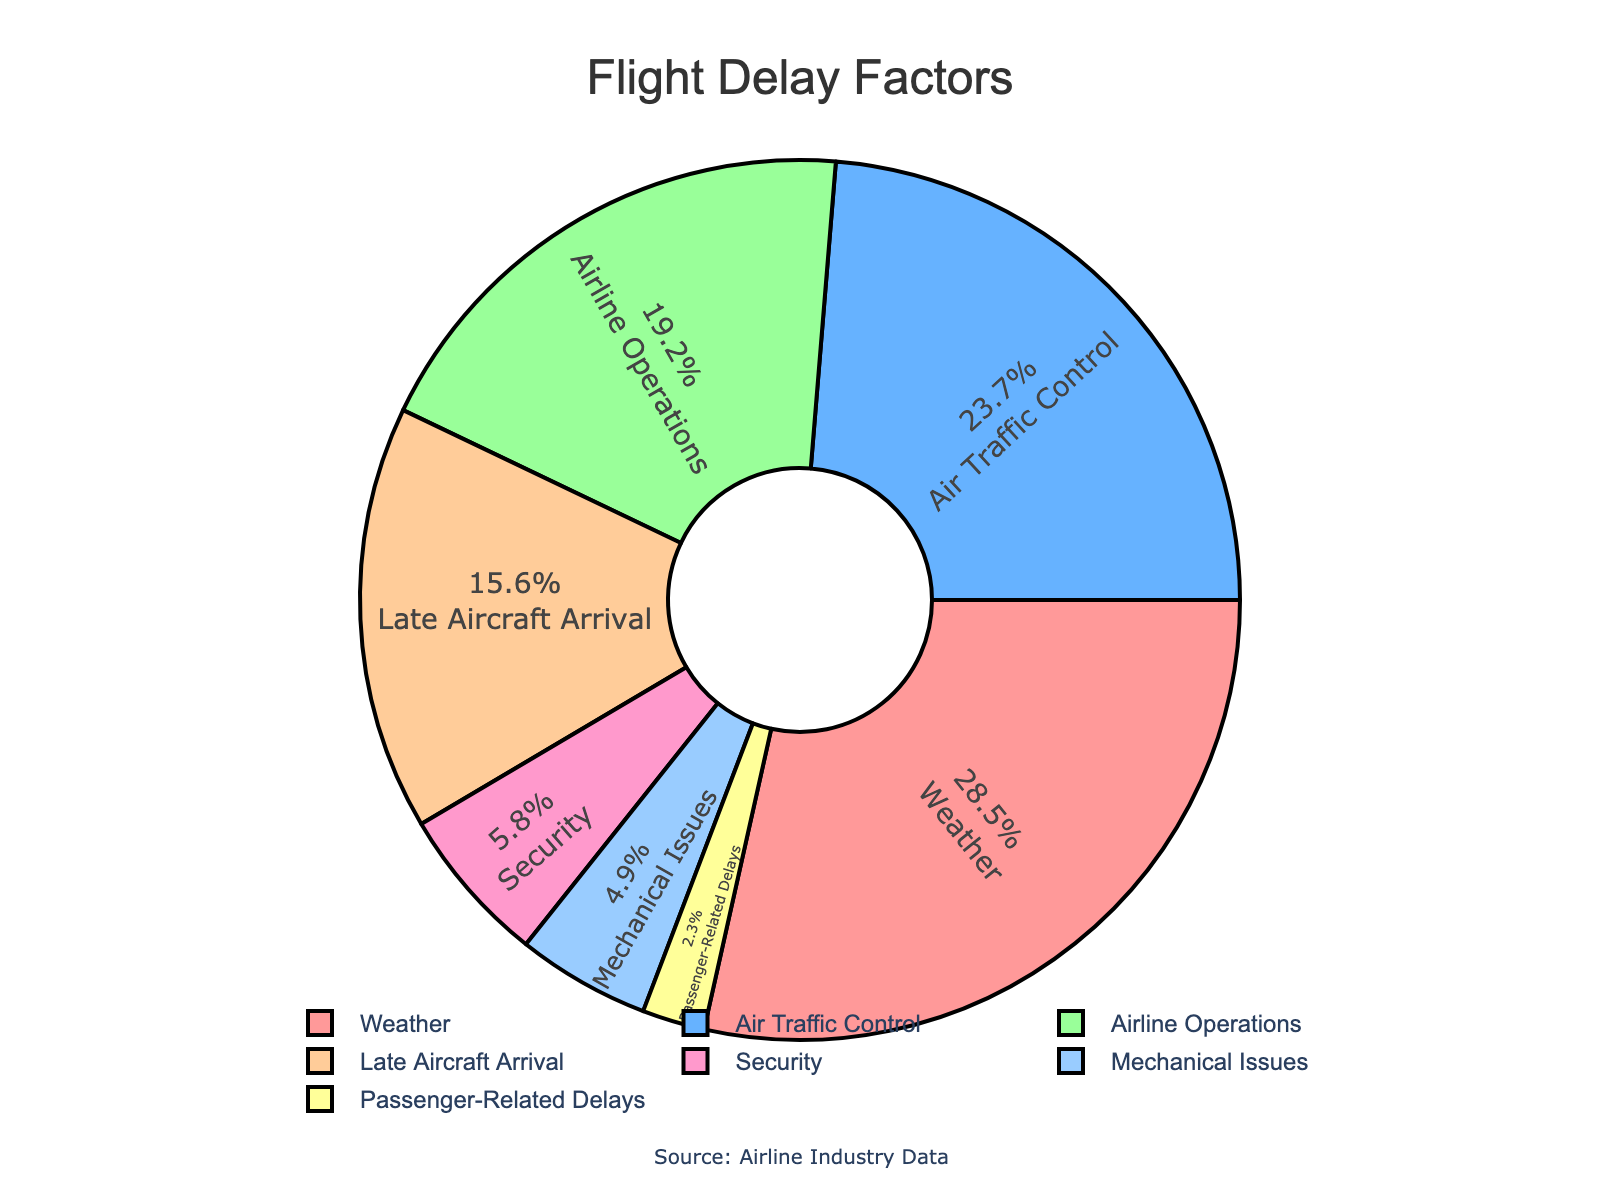What are the top three factors contributing to flight delays? Refer to the pie chart and identify the three largest sections by percentage. The top three factors are Weather (28.5%), Air Traffic Control (23.7%), and Airline Operations (19.2%).
Answer: Weather, Air Traffic Control, Airline Operations Which delay factor contributes the least to flight delays? Look at the pie chart and find the smallest section by percentage, which is Passenger-Related Delays at 2.3%.
Answer: Passenger-Related Delays How much more do weather-related delays contribute compared to mechanical issues? Subtract the percentage for Mechanical Issues (4.9%) from the percentage for Weather (28.5%). The difference is 28.5% - 4.9% = 23.6%.
Answer: 23.6% Are air traffic control and late aircraft arrival delays together more or less than weather-related delays? Add the percentages of Air Traffic Control (23.7%) and Late Aircraft Arrival (15.6%), which sums up to 23.7% + 15.6% = 39.3%. Weather-related delays are 28.5%. 39.3% is more than 28.5%.
Answer: More Which factor occupies the yellow section of the pie chart? Given that the colors are allocated to different factors and based on the description, the yellow section represents Late Aircraft Arrival.
Answer: Late Aircraft Arrival What percentage of delays are due to factors under airline control (Airline Operations, Mechanical Issues, Passenger-Related Delays)? Sum up the percentages for Airline Operations (19.2%), Mechanical Issues (4.9%), and Passenger-Related Delays (2.3%). The total is 19.2% + 4.9% + 2.3% = 26.4%.
Answer: 26.4% How does the percentage of security delays compare to mechanical issues? Security delays are 5.8% and Mechanical Issues are 4.9%. Since 5.8% is greater than 4.9%, Security delays contribute more.
Answer: Greater What percentage of delays is attributed to factors other than weather? Subtract the weather-related delays (28.5%) from 100% to find the percentage due to other factors. The calculation is 100% - 28.5% = 71.5%.
Answer: 71.5% 